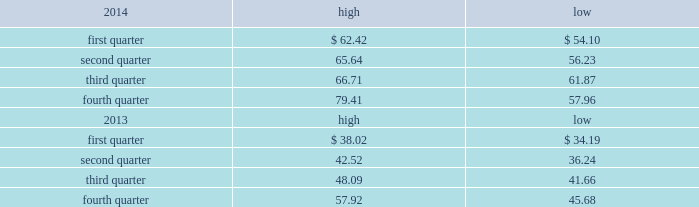Part ii item 5 .
Market for registrant 2019s common equity , related stockholder matters and issuer purchases of equity securities market price of and dividends on the registrant 2019s common equity and related stockholder matters market information .
Our class a common stock is quoted on the nasdaq global select market under the symbol 201cdish . 201d the high and low closing sale prices of our class a common stock during 2014 and 2013 on the nasdaq global select market ( as reported by nasdaq ) are set forth below. .
As of february 13 , 2015 , there were approximately 8208 holders of record of our class a common stock , not including stockholders who beneficially own class a common stock held in nominee or street name .
As of february 10 , 2015 , 213247004 of the 238435208 outstanding shares of our class b common stock were beneficially held by charles w .
Ergen , our chairman , and the remaining 25188204 were held in trusts established by mr .
Ergen for the benefit of his family .
There is currently no trading market for our class b common stock .
Dividends .
On december 28 , 2012 , we paid a cash dividend of $ 1.00 per share , or approximately $ 453 million , on our outstanding class a and class b common stock to stockholders of record at the close of business on december 14 , 2012 .
While we currently do not intend to declare additional dividends on our common stock , we may elect to do so from time to time .
Payment of any future dividends will depend upon our earnings and capital requirements , restrictions in our debt facilities , and other factors the board of directors considers appropriate .
We currently intend to retain our earnings , if any , to support future growth and expansion , although we may repurchase shares of our common stock from time to time .
See further discussion under 201citem 7 .
Management 2019s discussion and analysis of financial condition and results of operations 2013 liquidity and capital resources 201d in this annual report on form 10-k .
Securities authorized for issuance under equity compensation plans .
See 201citem 12 .
Security ownership of certain beneficial owners and management and related stockholder matters 201d in this annual report on form 10-k. .
How high did the stock price reach in january to march 2013? 
Computations: table_max(first quarter, none)
Answer: 38.02. 